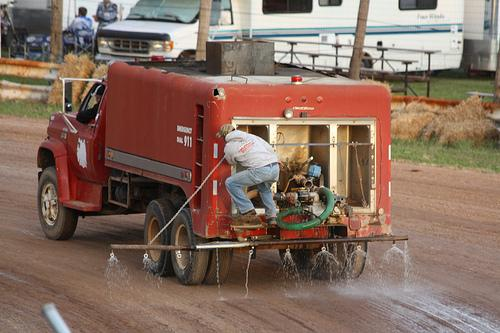Describe the most prominent object and its actions in the image. The red truck in the image is spraying water on a dusty road, while a man is on its back. Narrate the main focus of the image and its activity. The image highlights a red truck, which is sprinkling water on a dirt track, while a person stands on its rear. Write a short description of the main subject and what's happening in the image. The image showcases a red truck dispersing water on a dirt road with a man standing on its rear. Describe the focal point of the image and what is taking place. The image features a red truck that is spraying water on a dirt road, along with a man on its back. Summarize the primary object in the image and its actions. A red truck is seen showering water on a dirt road, while a man rides on its back. Provide a brief summary of the central object or action in the image. A red truck is sprinkling water on a dirt road with a person on its back. State the main object and its activity in the image. A red truck is the central object, seen spraying water on a dirt track. Provide a concise explanation of the most important subject in the image and its actions. The main subject is a red truck, which is splashing water on a dirt road, with a person riding on its back. In a few words, describe the significant object and what it's doing in the image. Red truck spraying water on a dirt road, with a man on the back. Identify the primary focus of the image and describe its features. A red truck spraying water on a dirt track, with a green hose attached and a man riding in the back. 